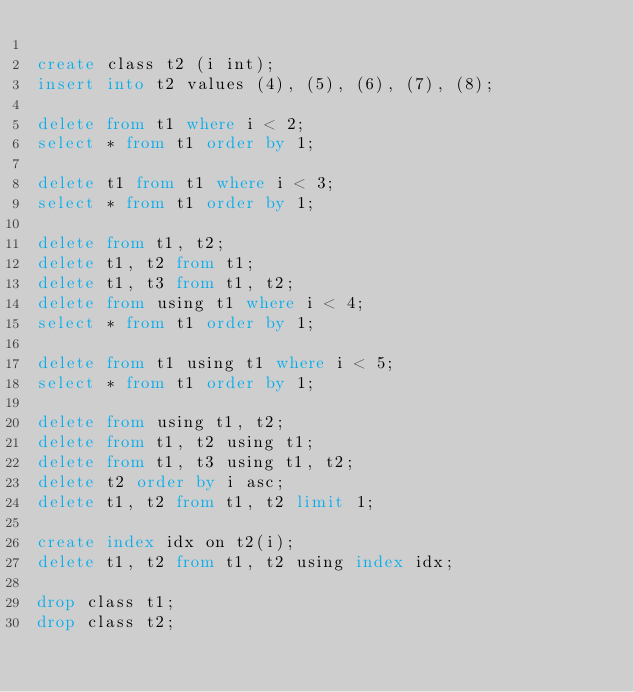Convert code to text. <code><loc_0><loc_0><loc_500><loc_500><_SQL_>
create class t2 (i int);
insert into t2 values (4), (5), (6), (7), (8);

delete from t1 where i < 2;
select * from t1 order by 1;

delete t1 from t1 where i < 3;
select * from t1 order by 1;

delete from t1, t2;
delete t1, t2 from t1;
delete t1, t3 from t1, t2;
delete from using t1 where i < 4;
select * from t1 order by 1;

delete from t1 using t1 where i < 5;
select * from t1 order by 1;

delete from using t1, t2;
delete from t1, t2 using t1;
delete from t1, t3 using t1, t2;
delete t2 order by i asc;
delete t1, t2 from t1, t2 limit 1;

create index idx on t2(i);
delete t1, t2 from t1, t2 using index idx;

drop class t1;
drop class t2;
</code> 